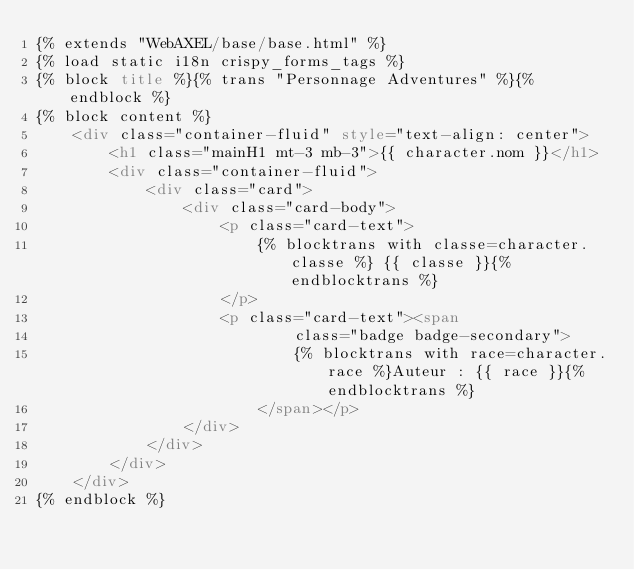<code> <loc_0><loc_0><loc_500><loc_500><_HTML_>{% extends "WebAXEL/base/base.html" %}
{% load static i18n crispy_forms_tags %}
{% block title %}{% trans "Personnage Adventures" %}{% endblock %}
{% block content %}
    <div class="container-fluid" style="text-align: center">
        <h1 class="mainH1 mt-3 mb-3">{{ character.nom }}</h1>
        <div class="container-fluid">
            <div class="card">
                <div class="card-body">
                    <p class="card-text">
                        {% blocktrans with classe=character.classe %} {{ classe }}{% endblocktrans %}
                    </p>
                    <p class="card-text"><span
                            class="badge badge-secondary">
                            {% blocktrans with race=character.race %}Auteur : {{ race }}{% endblocktrans %}
                        </span></p>
                </div>
            </div>
        </div>
    </div>
{% endblock %}</code> 